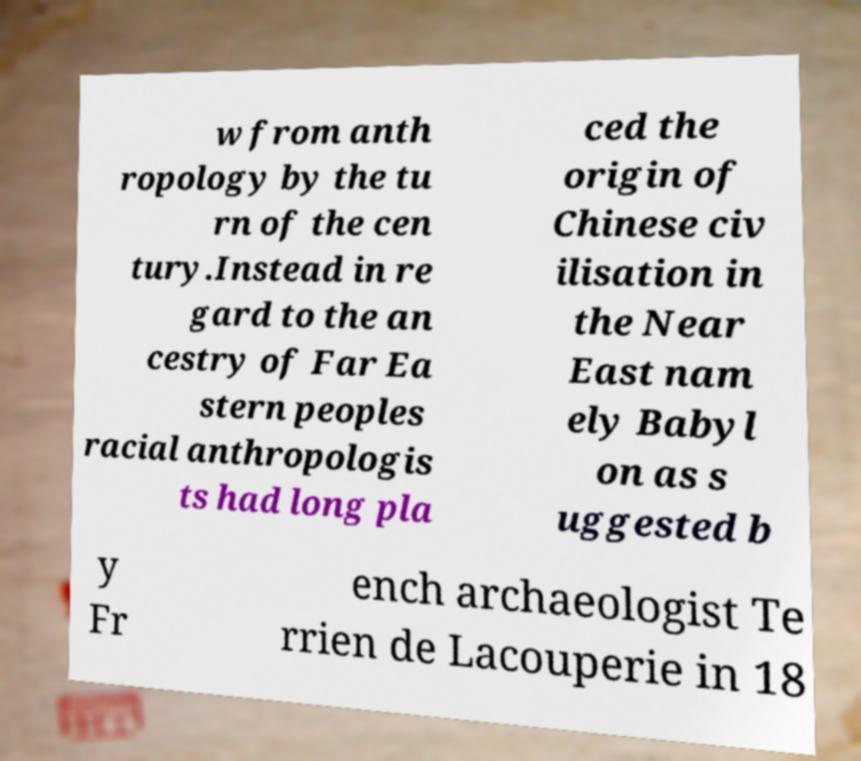For documentation purposes, I need the text within this image transcribed. Could you provide that? w from anth ropology by the tu rn of the cen tury.Instead in re gard to the an cestry of Far Ea stern peoples racial anthropologis ts had long pla ced the origin of Chinese civ ilisation in the Near East nam ely Babyl on as s uggested b y Fr ench archaeologist Te rrien de Lacouperie in 18 